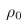<formula> <loc_0><loc_0><loc_500><loc_500>\rho _ { 0 }</formula> 